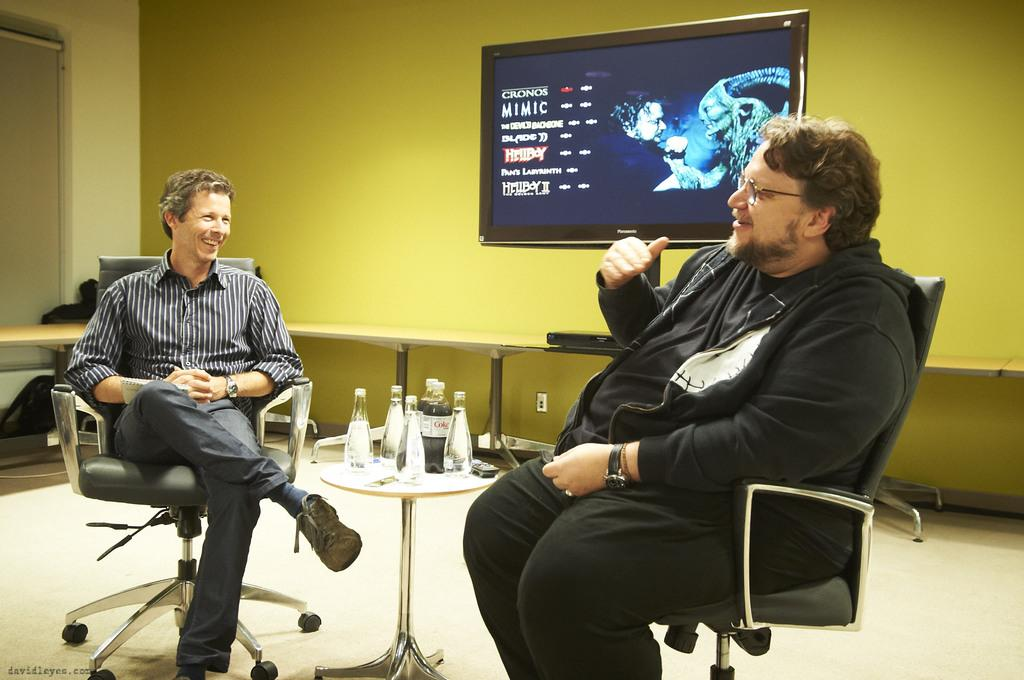How many people are in the image? There are two men in the image. What are the men doing in the image? The men are speaking to each other. What are the men sitting on in the image? The men are seated on chairs. What electronic device is present in the image? There is a television in the image. What can be seen on the table in the image? There are water bottles on a table. Is there a beggar asking for money in the image? No, there is no beggar present in the image. Are the men on vacation in the image? There is no indication in the image that the men are on vacation. 